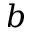<formula> <loc_0><loc_0><loc_500><loc_500>b</formula> 